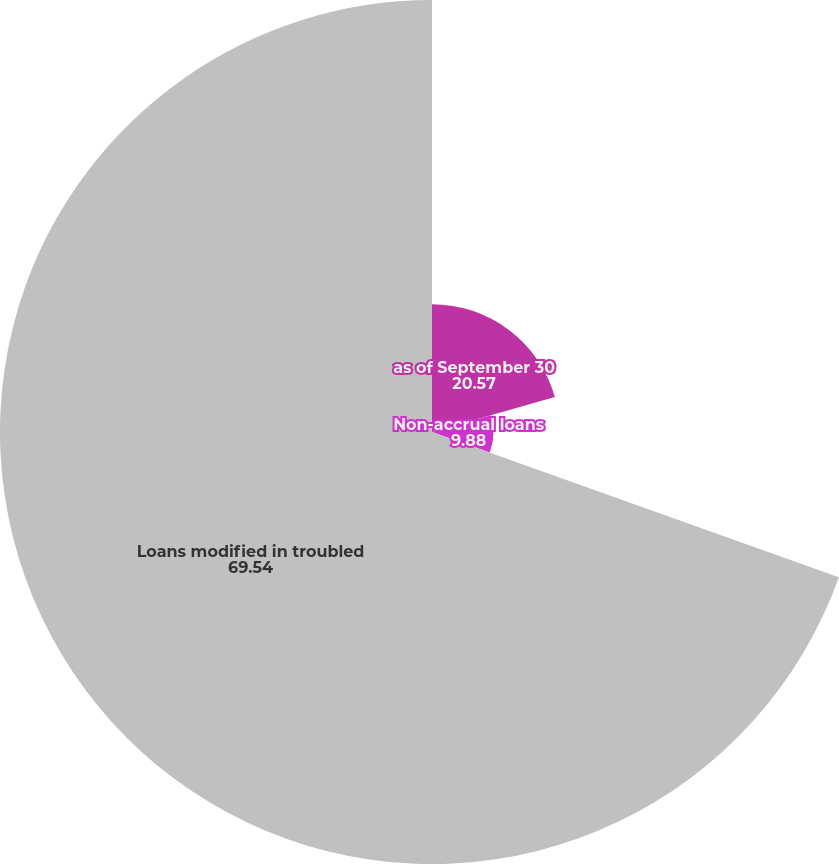Convert chart. <chart><loc_0><loc_0><loc_500><loc_500><pie_chart><fcel>as of September 30<fcel>Non-accrual loans<fcel>Loans modified in troubled<nl><fcel>20.57%<fcel>9.88%<fcel>69.54%<nl></chart> 